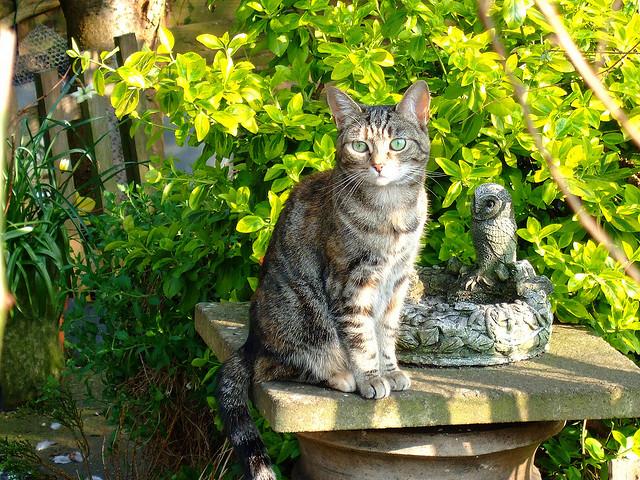Is the owl in this picture alive?
Be succinct. No. Is there a bird feeder in the place?
Concise answer only. Yes. What is the cat sitting on?
Write a very short answer. Bird bath. 